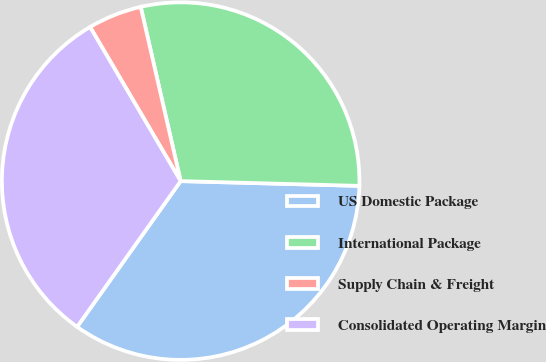Convert chart to OTSL. <chart><loc_0><loc_0><loc_500><loc_500><pie_chart><fcel>US Domestic Package<fcel>International Package<fcel>Supply Chain & Freight<fcel>Consolidated Operating Margin<nl><fcel>34.41%<fcel>29.01%<fcel>4.87%<fcel>31.71%<nl></chart> 